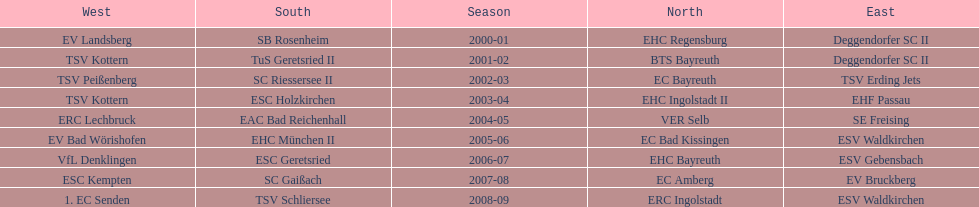Who won the season in the north before ec bayreuth did in 2002-03? BTS Bayreuth. 